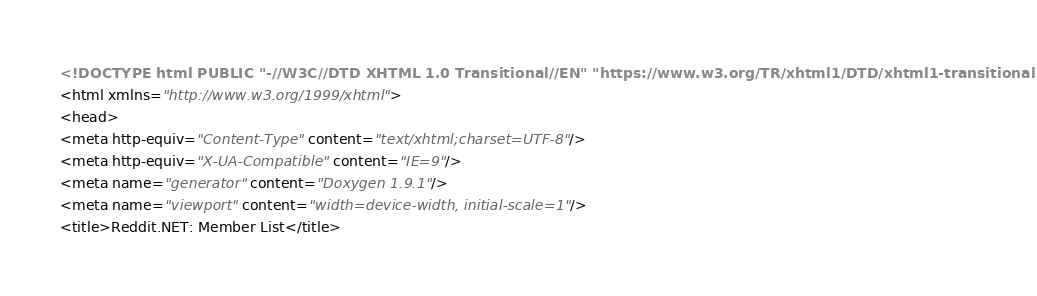Convert code to text. <code><loc_0><loc_0><loc_500><loc_500><_HTML_><!DOCTYPE html PUBLIC "-//W3C//DTD XHTML 1.0 Transitional//EN" "https://www.w3.org/TR/xhtml1/DTD/xhtml1-transitional.dtd">
<html xmlns="http://www.w3.org/1999/xhtml">
<head>
<meta http-equiv="Content-Type" content="text/xhtml;charset=UTF-8"/>
<meta http-equiv="X-UA-Compatible" content="IE=9"/>
<meta name="generator" content="Doxygen 1.9.1"/>
<meta name="viewport" content="width=device-width, initial-scale=1"/>
<title>Reddit.NET: Member List</title></code> 